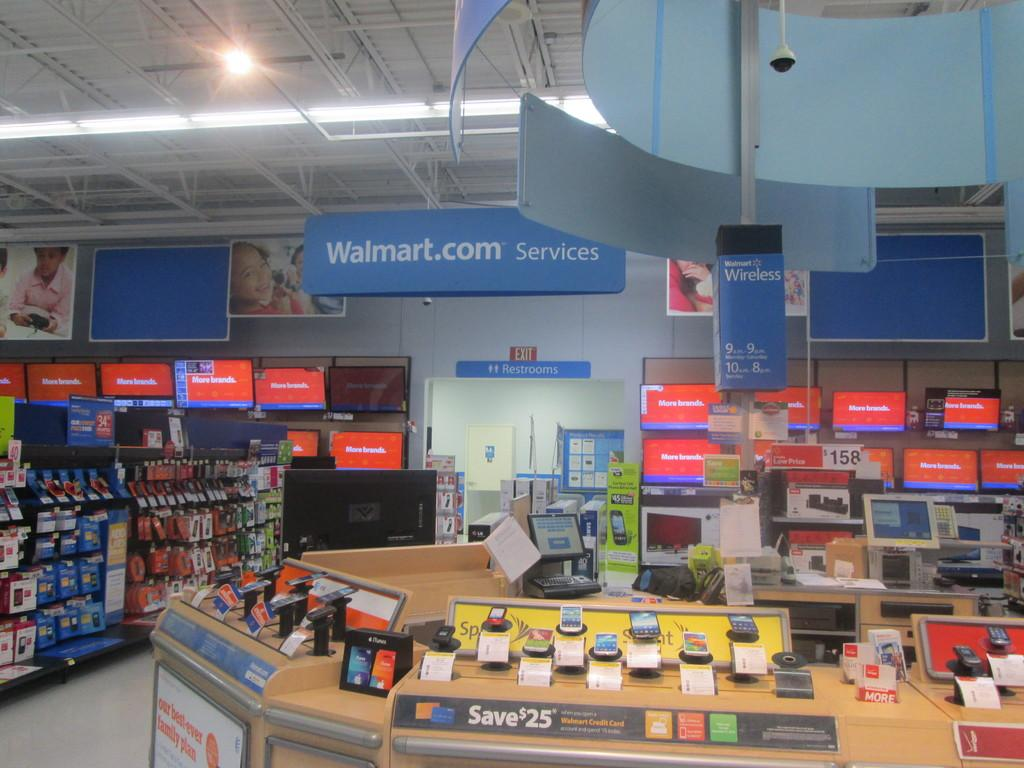<image>
Offer a succinct explanation of the picture presented. A display at walmart offering a 25 dollar discount. 